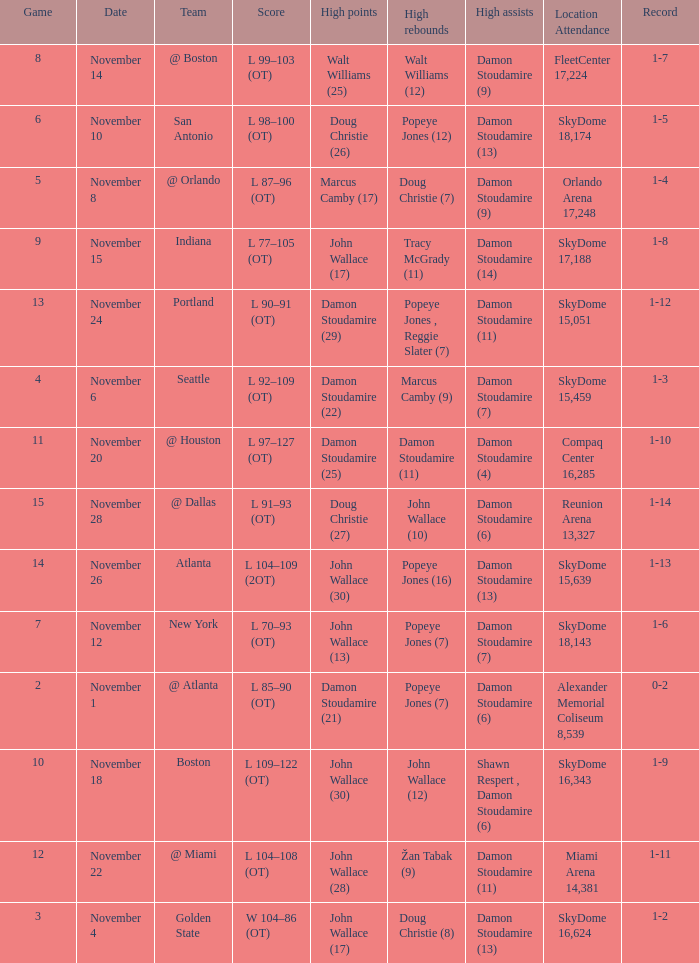How many games did the team play when they were 1-3? 1.0. 